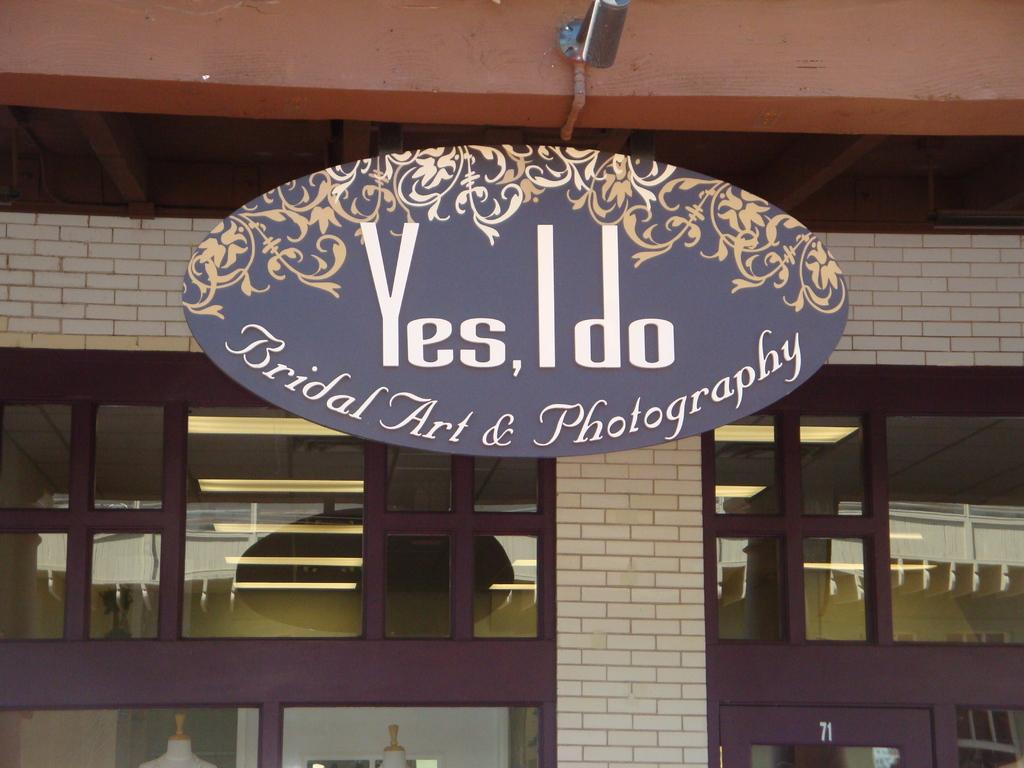<image>
Give a short and clear explanation of the subsequent image. The storefront of a Bridal Art & Photography studio. 